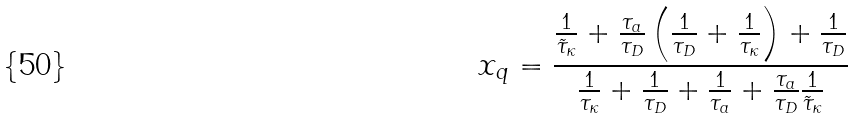<formula> <loc_0><loc_0><loc_500><loc_500>x _ { q } = \frac { \frac { 1 } { \tilde { \tau } _ { \kappa } } + \frac { \tau _ { a } } { \tau _ { D } } \left ( \frac { 1 } { \tau _ { D } } + \frac { 1 } { \tau _ { \kappa } } \right ) + \frac { 1 } { \tau _ { D } } } { \frac { 1 } { \tau _ { \kappa } } + \frac { 1 } { \tau _ { D } } + \frac { 1 } { \tau _ { a } } + \frac { \tau _ { a } } { \tau _ { D } } \frac { 1 } { \tilde { \tau } _ { \kappa } } }</formula> 